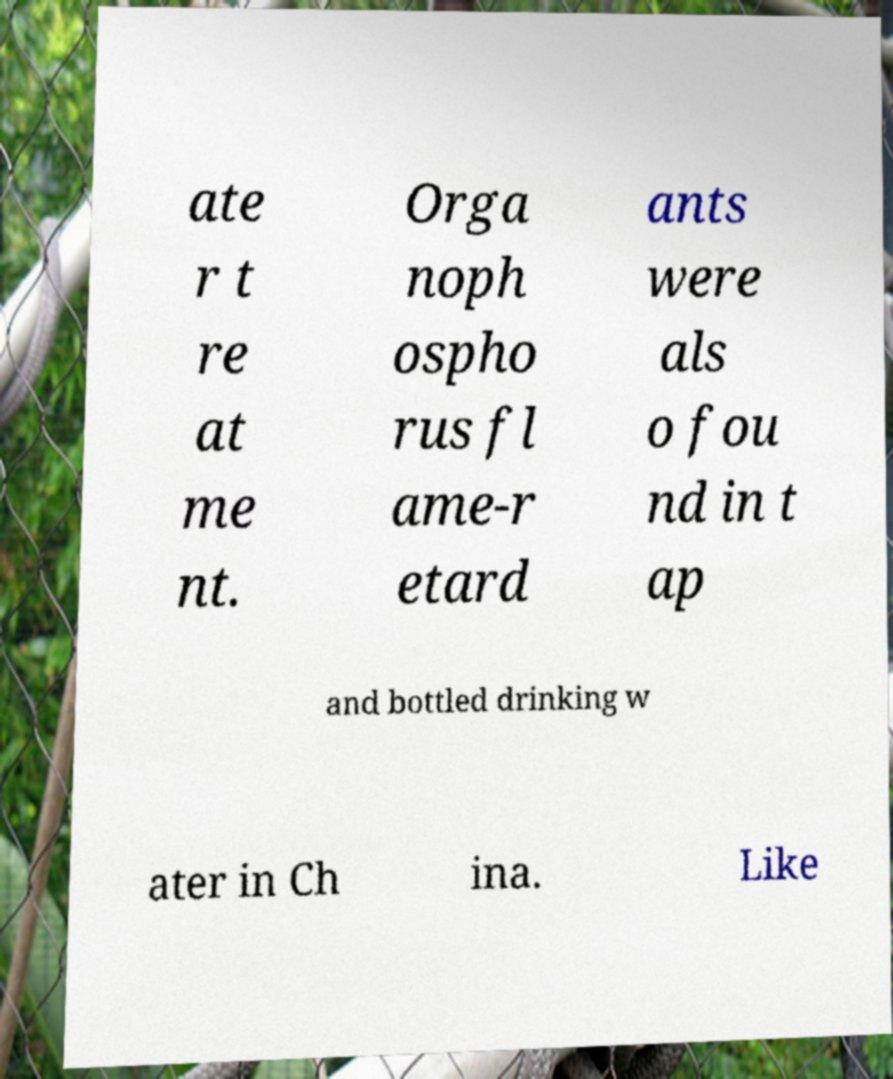What messages or text are displayed in this image? I need them in a readable, typed format. ate r t re at me nt. Orga noph ospho rus fl ame-r etard ants were als o fou nd in t ap and bottled drinking w ater in Ch ina. Like 